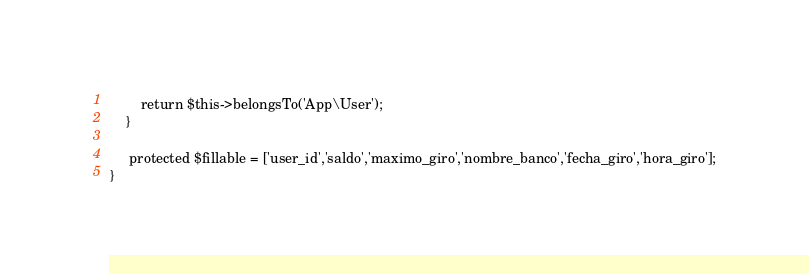Convert code to text. <code><loc_0><loc_0><loc_500><loc_500><_PHP_>        return $this->belongsTo('App\User');
    }

     protected $fillable = ['user_id','saldo','maximo_giro','nombre_banco','fecha_giro','hora_giro'];
}
</code> 